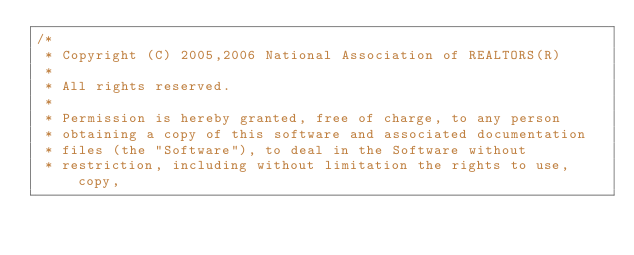<code> <loc_0><loc_0><loc_500><loc_500><_C_>/*
 * Copyright (C) 2005,2006 National Association of REALTORS(R)
 *
 * All rights reserved.
 *
 * Permission is hereby granted, free of charge, to any person
 * obtaining a copy of this software and associated documentation
 * files (the "Software"), to deal in the Software without
 * restriction, including without limitation the rights to use, copy,</code> 